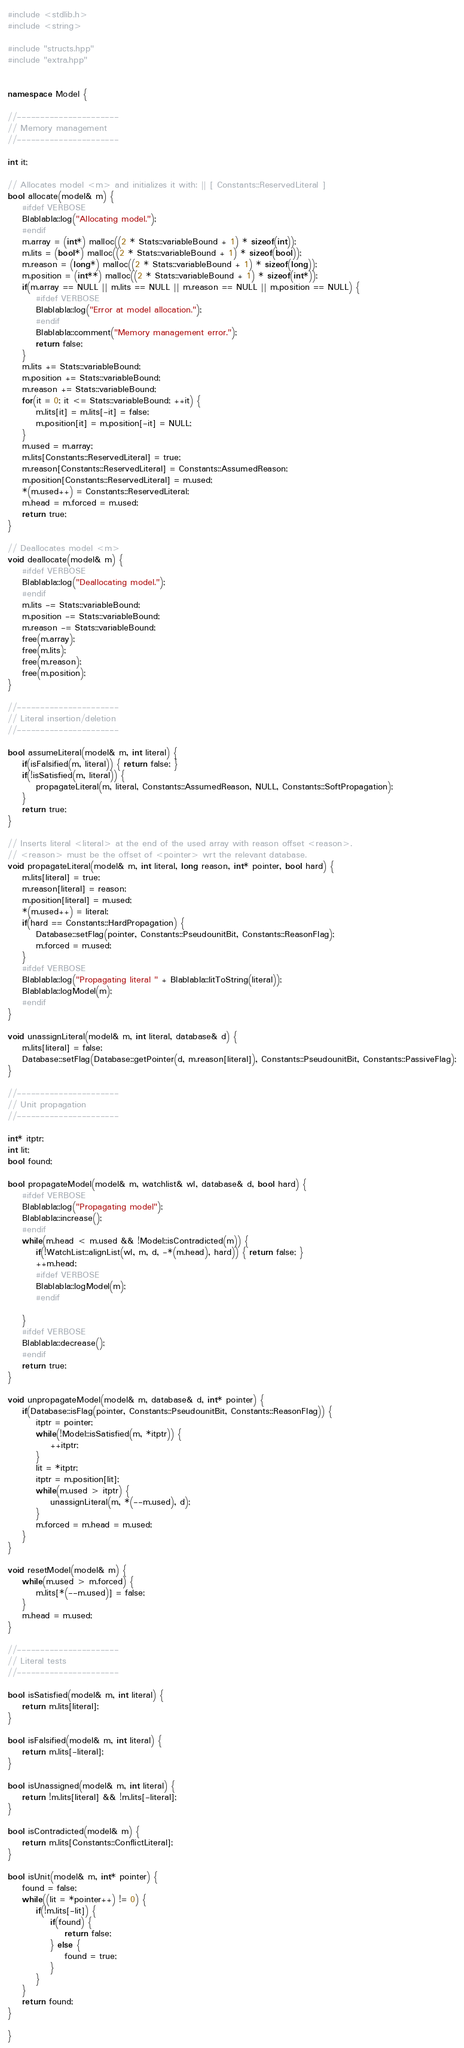<code> <loc_0><loc_0><loc_500><loc_500><_C++_>#include <stdlib.h>
#include <string>

#include "structs.hpp"
#include "extra.hpp"


namespace Model {

//----------------------
// Memory management
//----------------------

int it;

// Allocates model <m> and initializes it with: || [ Constants::ReservedLiteral ]
bool allocate(model& m) {
    #ifdef VERBOSE
    Blablabla::log("Allocating model.");
    #endif
    m.array = (int*) malloc((2 * Stats::variableBound + 1) * sizeof(int));
    m.lits = (bool*) malloc((2 * Stats::variableBound + 1) * sizeof(bool));
    m.reason = (long*) malloc((2 * Stats::variableBound + 1) * sizeof(long));
    m.position = (int**) malloc((2 * Stats::variableBound + 1) * sizeof(int*));
    if(m.array == NULL || m.lits == NULL || m.reason == NULL || m.position == NULL) {
        #ifdef VERBOSE
        Blablabla::log("Error at model allocation.");
        #endif
		Blablabla::comment("Memory management error.");
        return false;
    }
    m.lits += Stats::variableBound;
    m.position += Stats::variableBound;
    m.reason += Stats::variableBound;
    for(it = 0; it <= Stats::variableBound; ++it) {
        m.lits[it] = m.lits[-it] = false;
        m.position[it] = m.position[-it] = NULL;
    }
    m.used = m.array;
    m.lits[Constants::ReservedLiteral] = true;
    m.reason[Constants::ReservedLiteral] = Constants::AssumedReason;
    m.position[Constants::ReservedLiteral] = m.used;
    *(m.used++) = Constants::ReservedLiteral;
    m.head = m.forced = m.used;
    return true;
}

// Deallocates model <m>
void deallocate(model& m) {
    #ifdef VERBOSE
    Blablabla::log("Deallocating model.");
    #endif
    m.lits -= Stats::variableBound;
    m.position -= Stats::variableBound;
    m.reason -= Stats::variableBound;
    free(m.array);
    free(m.lits);
    free(m.reason);
    free(m.position);
}

//----------------------
// Literal insertion/deletion
//----------------------

bool assumeLiteral(model& m, int literal) {
    if(isFalsified(m, literal)) { return false; }
    if(!isSatisfied(m, literal)) {
        propagateLiteral(m, literal, Constants::AssumedReason, NULL, Constants::SoftPropagation);
    }
    return true;
}

// Inserts literal <literal> at the end of the used array with reason offset <reason>.
// <reason> must be the offset of <pointer> wrt the relevant database.
void propagateLiteral(model& m, int literal, long reason, int* pointer, bool hard) {
    m.lits[literal] = true;
    m.reason[literal] = reason;
    m.position[literal] = m.used;
    *(m.used++) = literal;
    if(hard == Constants::HardPropagation) {
        Database::setFlag(pointer, Constants::PseudounitBit, Constants::ReasonFlag);
        m.forced = m.used;
    }
    #ifdef VERBOSE
    Blablabla::log("Propagating literal " + Blablabla::litToString(literal));
    Blablabla::logModel(m);
    #endif
}

void unassignLiteral(model& m, int literal, database& d) {
    m.lits[literal] = false;
    Database::setFlag(Database::getPointer(d, m.reason[literal]), Constants::PseudounitBit, Constants::PassiveFlag);
}

//----------------------
// Unit propagation
//----------------------

int* itptr;
int lit;
bool found;

bool propagateModel(model& m, watchlist& wl, database& d, bool hard) {
    #ifdef VERBOSE
    Blablabla::log("Propagating model");
    Blablabla::increase();
    #endif
    while(m.head < m.used && !Model::isContradicted(m)) {
        if(!WatchList::alignList(wl, m, d, -*(m.head), hard)) { return false; }
        ++m.head;
        #ifdef VERBOSE
        Blablabla::logModel(m);
        #endif

    }
    #ifdef VERBOSE
    Blablabla::decrease();
    #endif
    return true;
}

void unpropagateModel(model& m, database& d, int* pointer) {
    if(Database::isFlag(pointer, Constants::PseudounitBit, Constants::ReasonFlag)) {
        itptr = pointer;
        while(!Model::isSatisfied(m, *itptr)) {
            ++itptr;
        }
        lit = *itptr;
        itptr = m.position[lit];
        while(m.used > itptr) {
            unassignLiteral(m, *(--m.used), d);
        }
        m.forced = m.head = m.used;
    }
}

void resetModel(model& m) {
    while(m.used > m.forced) {
        m.lits[*(--m.used)] = false;
    }
    m.head = m.used;
}

//----------------------
// Literal tests
//----------------------

bool isSatisfied(model& m, int literal) {
    return m.lits[literal];
}

bool isFalsified(model& m, int literal) {
    return m.lits[-literal];
}

bool isUnassigned(model& m, int literal) {
    return !m.lits[literal] && !m.lits[-literal];
}

bool isContradicted(model& m) {
    return m.lits[Constants::ConflictLiteral];
}

bool isUnit(model& m, int* pointer) {
    found = false;
    while((lit = *pointer++) != 0) {
        if(!m.lits[-lit]) {
            if(found) {
                return false;
            } else {
                found = true;
            }
        }
    }
    return found;
}

}
</code> 